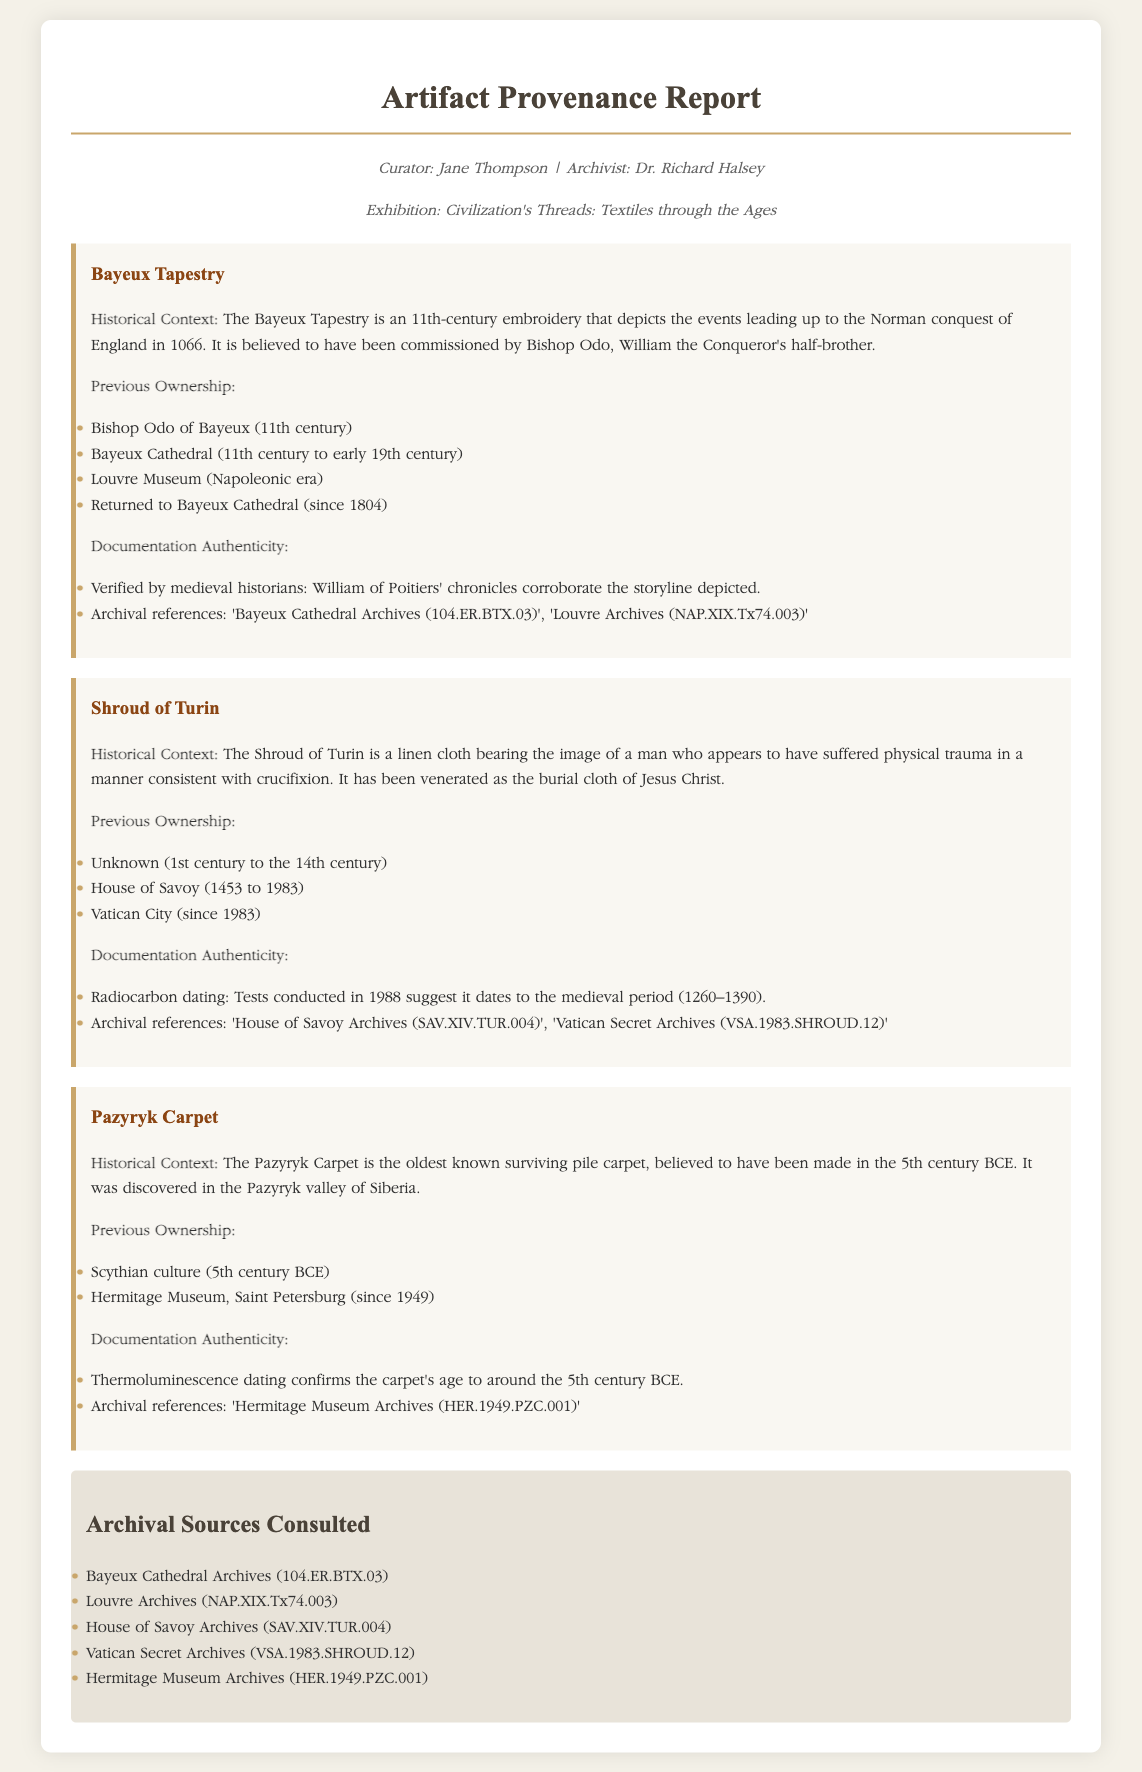What is the title of the report? The title of the report is stated at the top of the document.
Answer: Artifact Provenance Report Who is the curator of the exhibition? The curator's name is mentioned in the meta section of the document.
Answer: Jane Thompson What century does the Bayeux Tapestry date back to? The specific century is identified in the historical context of the artifact.
Answer: 11th century Which museum did the Shroud of Turin belong to from 1453 to 1983? The previous ownership details provide this information about the Shroud of Turin.
Answer: House of Savoy What is the oldest known surviving pile carpet? The historical context of the artifacts mentions the oldest one.
Answer: Pazyryk Carpet How many archival sources are consulted in the report? The sources section lists the number of archival references consulted for the report.
Answer: Five What type of dating confirms the Pazyryk Carpet's age? The documentation authenticity section specifies the method of dating.
Answer: Thermoluminescence What year was the Bayeux Tapestry returned to Bayeux Cathedral? The previous ownership details include the year in which this event occurred.
Answer: 1804 Who verified the authenticity of the Bayeux Tapestry? The documentation authenticity section mentions the involved historians.
Answer: Medieval historians 